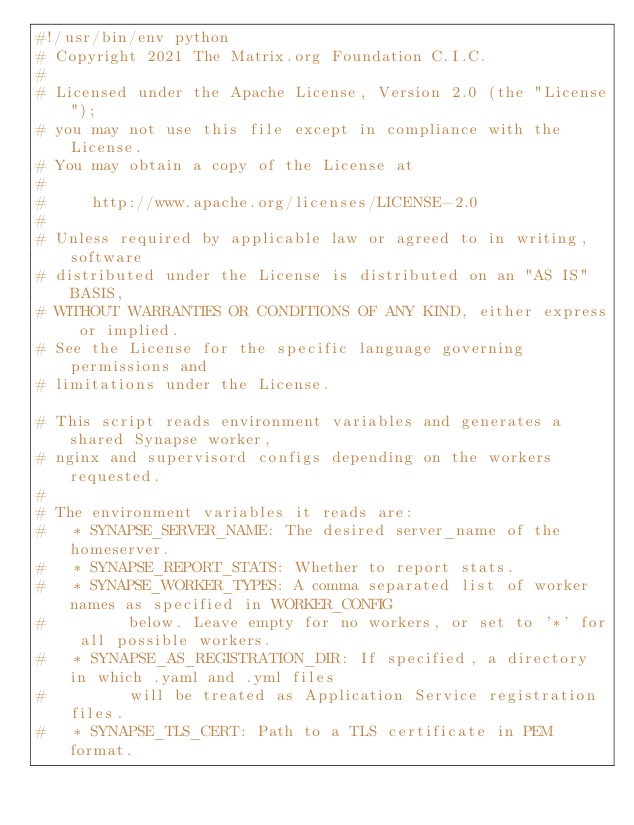Convert code to text. <code><loc_0><loc_0><loc_500><loc_500><_Python_>#!/usr/bin/env python
# Copyright 2021 The Matrix.org Foundation C.I.C.
#
# Licensed under the Apache License, Version 2.0 (the "License");
# you may not use this file except in compliance with the License.
# You may obtain a copy of the License at
#
#     http://www.apache.org/licenses/LICENSE-2.0
#
# Unless required by applicable law or agreed to in writing, software
# distributed under the License is distributed on an "AS IS" BASIS,
# WITHOUT WARRANTIES OR CONDITIONS OF ANY KIND, either express or implied.
# See the License for the specific language governing permissions and
# limitations under the License.

# This script reads environment variables and generates a shared Synapse worker,
# nginx and supervisord configs depending on the workers requested.
#
# The environment variables it reads are:
#   * SYNAPSE_SERVER_NAME: The desired server_name of the homeserver.
#   * SYNAPSE_REPORT_STATS: Whether to report stats.
#   * SYNAPSE_WORKER_TYPES: A comma separated list of worker names as specified in WORKER_CONFIG
#         below. Leave empty for no workers, or set to '*' for all possible workers.
#   * SYNAPSE_AS_REGISTRATION_DIR: If specified, a directory in which .yaml and .yml files
#         will be treated as Application Service registration files.
#   * SYNAPSE_TLS_CERT: Path to a TLS certificate in PEM format.</code> 